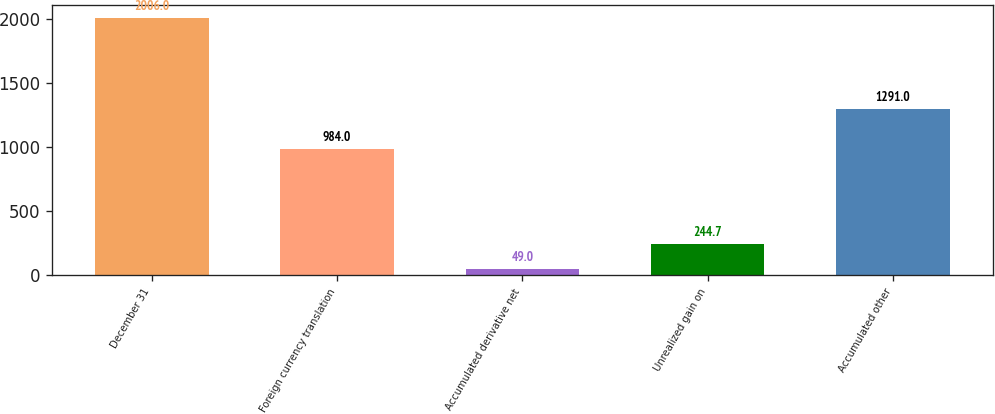Convert chart to OTSL. <chart><loc_0><loc_0><loc_500><loc_500><bar_chart><fcel>December 31<fcel>Foreign currency translation<fcel>Accumulated derivative net<fcel>Unrealized gain on<fcel>Accumulated other<nl><fcel>2006<fcel>984<fcel>49<fcel>244.7<fcel>1291<nl></chart> 